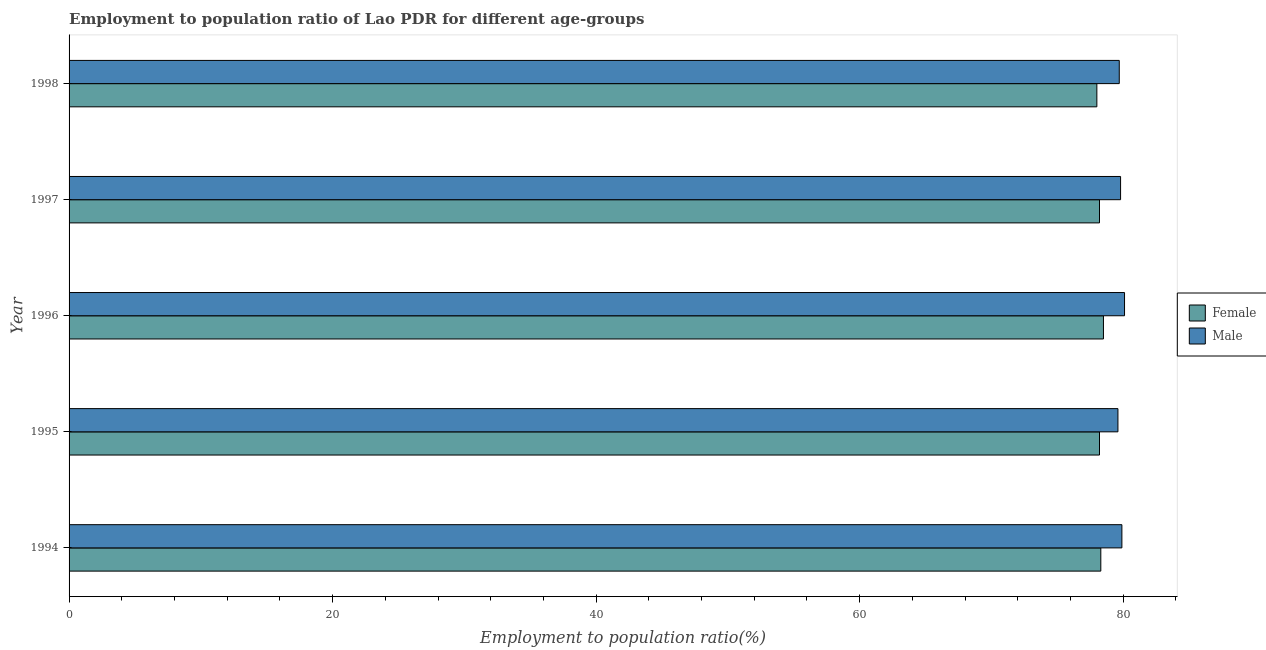Are the number of bars on each tick of the Y-axis equal?
Give a very brief answer. Yes. How many bars are there on the 5th tick from the top?
Ensure brevity in your answer.  2. What is the label of the 3rd group of bars from the top?
Your answer should be compact. 1996. What is the employment to population ratio(male) in 1998?
Your answer should be very brief. 79.7. Across all years, what is the maximum employment to population ratio(female)?
Give a very brief answer. 78.5. In which year was the employment to population ratio(female) maximum?
Ensure brevity in your answer.  1996. In which year was the employment to population ratio(female) minimum?
Make the answer very short. 1998. What is the total employment to population ratio(female) in the graph?
Ensure brevity in your answer.  391.2. What is the difference between the employment to population ratio(female) in 1998 and the employment to population ratio(male) in 1997?
Give a very brief answer. -1.8. What is the average employment to population ratio(female) per year?
Make the answer very short. 78.24. What is the ratio of the employment to population ratio(female) in 1994 to that in 1998?
Provide a short and direct response. 1. Is the employment to population ratio(female) in 1995 less than that in 1998?
Your answer should be compact. No. How many bars are there?
Your answer should be compact. 10. Are all the bars in the graph horizontal?
Keep it short and to the point. Yes. What is the difference between two consecutive major ticks on the X-axis?
Offer a terse response. 20. Does the graph contain grids?
Your answer should be very brief. No. How are the legend labels stacked?
Provide a short and direct response. Vertical. What is the title of the graph?
Keep it short and to the point. Employment to population ratio of Lao PDR for different age-groups. What is the Employment to population ratio(%) of Female in 1994?
Your answer should be compact. 78.3. What is the Employment to population ratio(%) of Male in 1994?
Your answer should be compact. 79.9. What is the Employment to population ratio(%) of Female in 1995?
Give a very brief answer. 78.2. What is the Employment to population ratio(%) of Male in 1995?
Offer a terse response. 79.6. What is the Employment to population ratio(%) of Female in 1996?
Keep it short and to the point. 78.5. What is the Employment to population ratio(%) of Male in 1996?
Make the answer very short. 80.1. What is the Employment to population ratio(%) in Female in 1997?
Provide a short and direct response. 78.2. What is the Employment to population ratio(%) of Male in 1997?
Provide a succinct answer. 79.8. What is the Employment to population ratio(%) in Male in 1998?
Offer a very short reply. 79.7. Across all years, what is the maximum Employment to population ratio(%) in Female?
Your answer should be very brief. 78.5. Across all years, what is the maximum Employment to population ratio(%) in Male?
Your answer should be compact. 80.1. Across all years, what is the minimum Employment to population ratio(%) in Female?
Give a very brief answer. 78. Across all years, what is the minimum Employment to population ratio(%) in Male?
Give a very brief answer. 79.6. What is the total Employment to population ratio(%) in Female in the graph?
Your answer should be very brief. 391.2. What is the total Employment to population ratio(%) of Male in the graph?
Offer a very short reply. 399.1. What is the difference between the Employment to population ratio(%) of Female in 1994 and that in 1995?
Your answer should be compact. 0.1. What is the difference between the Employment to population ratio(%) in Male in 1994 and that in 1995?
Your answer should be very brief. 0.3. What is the difference between the Employment to population ratio(%) of Male in 1994 and that in 1996?
Offer a very short reply. -0.2. What is the difference between the Employment to population ratio(%) of Female in 1994 and that in 1997?
Offer a very short reply. 0.1. What is the difference between the Employment to population ratio(%) of Female in 1994 and that in 1998?
Your answer should be compact. 0.3. What is the difference between the Employment to population ratio(%) in Male in 1995 and that in 1996?
Provide a succinct answer. -0.5. What is the difference between the Employment to population ratio(%) in Female in 1995 and that in 1997?
Ensure brevity in your answer.  0. What is the difference between the Employment to population ratio(%) in Male in 1995 and that in 1997?
Your answer should be very brief. -0.2. What is the difference between the Employment to population ratio(%) of Female in 1996 and that in 1997?
Offer a terse response. 0.3. What is the difference between the Employment to population ratio(%) in Male in 1996 and that in 1997?
Offer a terse response. 0.3. What is the difference between the Employment to population ratio(%) in Female in 1996 and that in 1998?
Provide a short and direct response. 0.5. What is the difference between the Employment to population ratio(%) in Female in 1997 and that in 1998?
Your response must be concise. 0.2. What is the difference between the Employment to population ratio(%) of Male in 1997 and that in 1998?
Give a very brief answer. 0.1. What is the difference between the Employment to population ratio(%) of Female in 1994 and the Employment to population ratio(%) of Male in 1995?
Keep it short and to the point. -1.3. What is the difference between the Employment to population ratio(%) in Female in 1994 and the Employment to population ratio(%) in Male in 1996?
Give a very brief answer. -1.8. What is the difference between the Employment to population ratio(%) in Female in 1994 and the Employment to population ratio(%) in Male in 1997?
Your response must be concise. -1.5. What is the difference between the Employment to population ratio(%) in Female in 1995 and the Employment to population ratio(%) in Male in 1996?
Offer a very short reply. -1.9. What is the difference between the Employment to population ratio(%) in Female in 1995 and the Employment to population ratio(%) in Male in 1997?
Provide a short and direct response. -1.6. What is the difference between the Employment to population ratio(%) in Female in 1995 and the Employment to population ratio(%) in Male in 1998?
Provide a succinct answer. -1.5. What is the average Employment to population ratio(%) of Female per year?
Your response must be concise. 78.24. What is the average Employment to population ratio(%) in Male per year?
Offer a terse response. 79.82. In the year 1995, what is the difference between the Employment to population ratio(%) in Female and Employment to population ratio(%) in Male?
Keep it short and to the point. -1.4. What is the ratio of the Employment to population ratio(%) in Female in 1994 to that in 1995?
Ensure brevity in your answer.  1. What is the ratio of the Employment to population ratio(%) in Male in 1994 to that in 1996?
Your response must be concise. 1. What is the ratio of the Employment to population ratio(%) in Female in 1994 to that in 1997?
Ensure brevity in your answer.  1. What is the ratio of the Employment to population ratio(%) in Female in 1994 to that in 1998?
Offer a very short reply. 1. What is the ratio of the Employment to population ratio(%) in Female in 1995 to that in 1996?
Ensure brevity in your answer.  1. What is the ratio of the Employment to population ratio(%) in Male in 1995 to that in 1996?
Ensure brevity in your answer.  0.99. What is the ratio of the Employment to population ratio(%) in Male in 1995 to that in 1997?
Provide a short and direct response. 1. What is the ratio of the Employment to population ratio(%) in Male in 1995 to that in 1998?
Your answer should be compact. 1. What is the ratio of the Employment to population ratio(%) of Female in 1996 to that in 1997?
Your answer should be very brief. 1. What is the ratio of the Employment to population ratio(%) of Female in 1996 to that in 1998?
Your response must be concise. 1.01. What is the ratio of the Employment to population ratio(%) of Female in 1997 to that in 1998?
Provide a succinct answer. 1. What is the difference between the highest and the second highest Employment to population ratio(%) of Male?
Your response must be concise. 0.2. What is the difference between the highest and the lowest Employment to population ratio(%) of Male?
Keep it short and to the point. 0.5. 